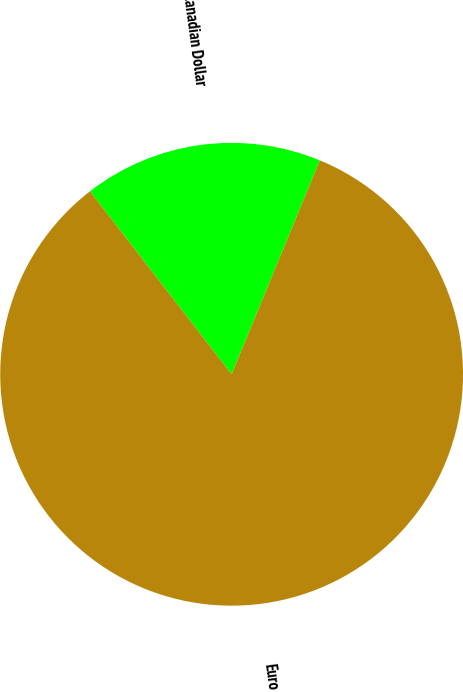<chart> <loc_0><loc_0><loc_500><loc_500><pie_chart><fcel>Canadian Dollar<fcel>Euro<nl><fcel>16.71%<fcel>83.29%<nl></chart> 